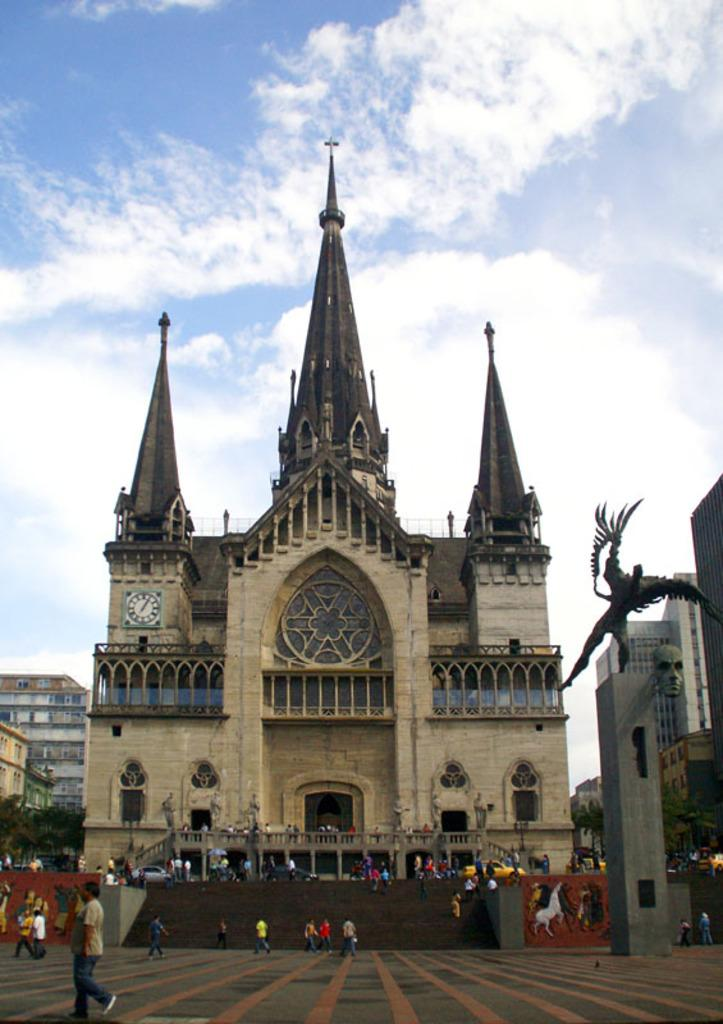What type of structures can be seen in the image? There are buildings in the image. Are there any living beings present in the image? Yes, there are people in the image. What artistic element can be found in the image? There is a sculpture in the image. What else can be seen in the image besides the buildings, people, and sculpture? There are other objects in the image. What part of the natural environment is visible in the image? The sky is visible at the top of the image, and the floor is visible at the bottom of the image. Can you tell me how many ghosts are interacting with the sculpture in the image? There are no ghosts present in the image; it only features buildings, people, and other objects. What type of memory is being stored in the sculpture in the image? The sculpture in the image is not a storage device for memories; it is an artistic element. 